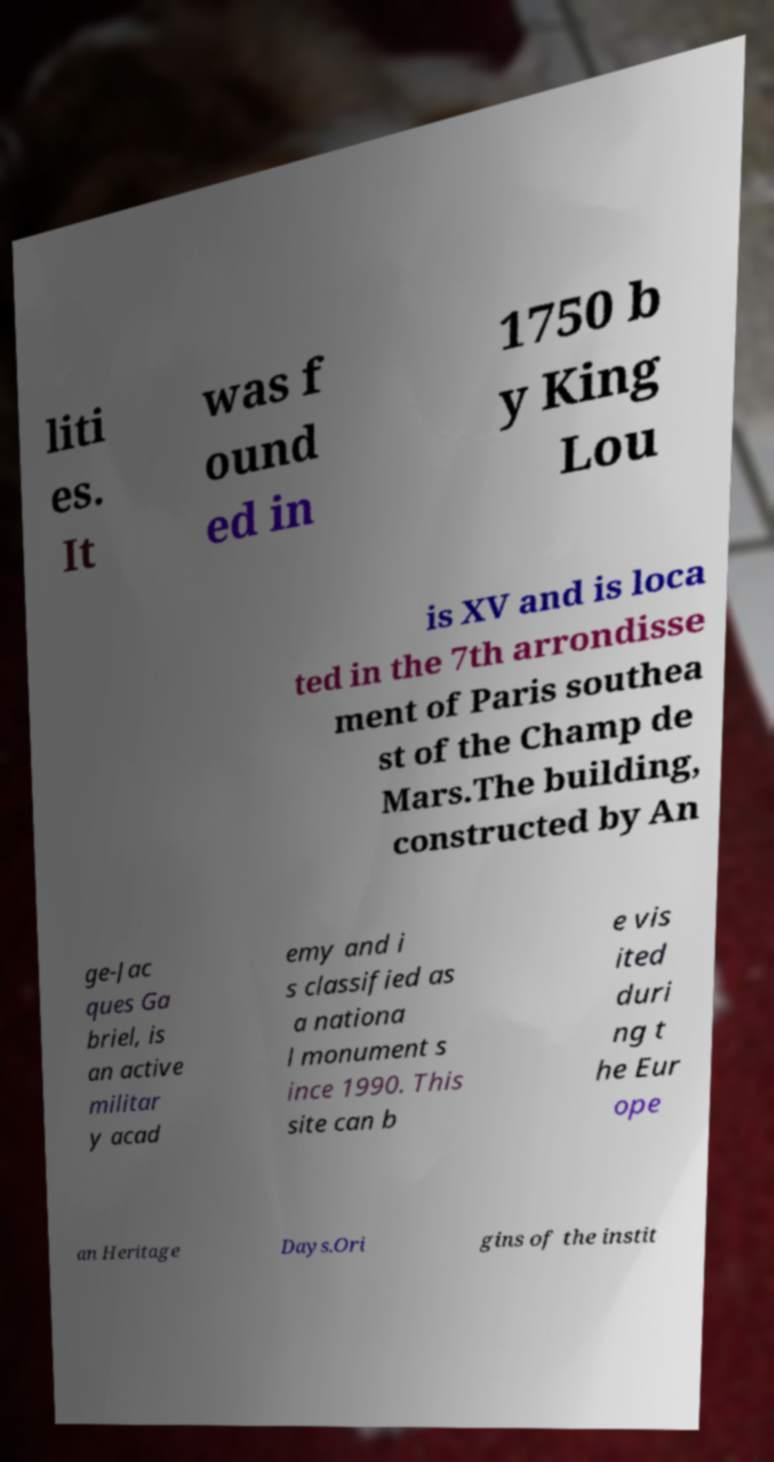What messages or text are displayed in this image? I need them in a readable, typed format. liti es. It was f ound ed in 1750 b y King Lou is XV and is loca ted in the 7th arrondisse ment of Paris southea st of the Champ de Mars.The building, constructed by An ge-Jac ques Ga briel, is an active militar y acad emy and i s classified as a nationa l monument s ince 1990. This site can b e vis ited duri ng t he Eur ope an Heritage Days.Ori gins of the instit 